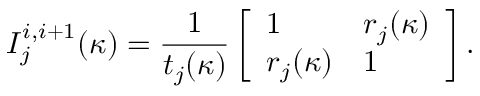<formula> <loc_0><loc_0><loc_500><loc_500>I _ { j } ^ { i , i + 1 } ( \kappa ) = \frac { 1 } { t _ { j } ( \kappa ) } \left [ \begin{array} { l l } { 1 } & { r _ { j } ( \kappa ) } \\ { r _ { j } ( \kappa ) } & { 1 } \end{array} \right ] .</formula> 